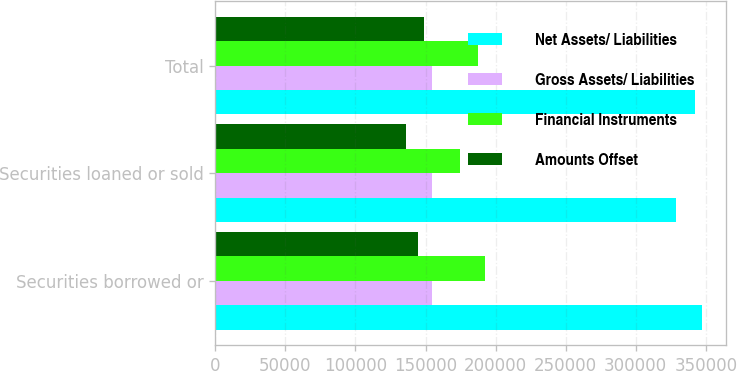<chart> <loc_0><loc_0><loc_500><loc_500><stacked_bar_chart><ecel><fcel>Securities borrowed or<fcel>Securities loaned or sold<fcel>Total<nl><fcel>Net Assets/ Liabilities<fcel>347281<fcel>329078<fcel>342313<nl><fcel>Gross Assets/ Liabilities<fcel>154799<fcel>154799<fcel>154799<nl><fcel>Financial Instruments<fcel>192482<fcel>174279<fcel>187514<nl><fcel>Amounts Offset<fcel>144332<fcel>135737<fcel>148972<nl></chart> 